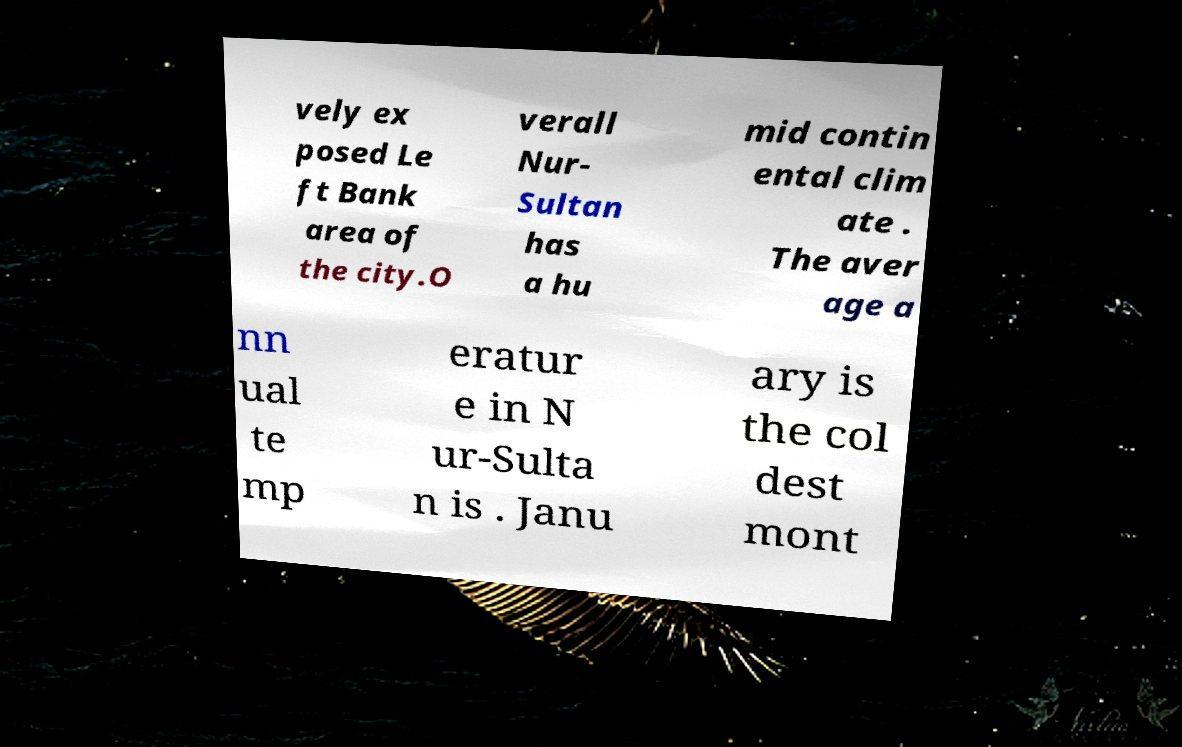For documentation purposes, I need the text within this image transcribed. Could you provide that? vely ex posed Le ft Bank area of the city.O verall Nur- Sultan has a hu mid contin ental clim ate . The aver age a nn ual te mp eratur e in N ur-Sulta n is . Janu ary is the col dest mont 